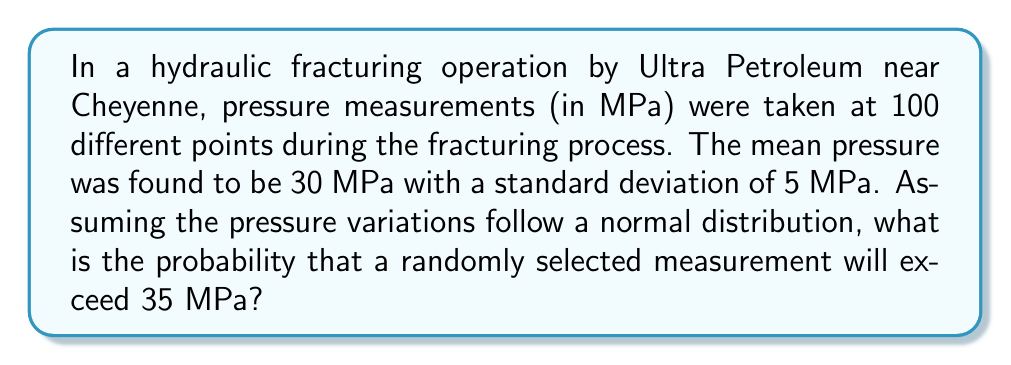Solve this math problem. To solve this problem, we'll use the properties of the normal distribution and the concept of z-scores.

Step 1: Identify the given information
- Mean pressure (μ) = 30 MPa
- Standard deviation (σ) = 5 MPa
- We want to find P(X > 35), where X is a random pressure measurement

Step 2: Calculate the z-score for 35 MPa
The z-score formula is: $z = \frac{x - \mu}{\sigma}$

$z = \frac{35 - 30}{5} = 1$

Step 3: Use the standard normal distribution table or calculator
We need to find P(Z > 1), where Z is a standard normal random variable.

P(Z > 1) = 1 - P(Z ≤ 1)

Using a standard normal table or calculator:
P(Z ≤ 1) ≈ 0.8413

Therefore, P(Z > 1) = 1 - 0.8413 = 0.1587

Step 4: Interpret the result
The probability that a randomly selected pressure measurement will exceed 35 MPa is approximately 0.1587 or 15.87%.
Answer: 0.1587 